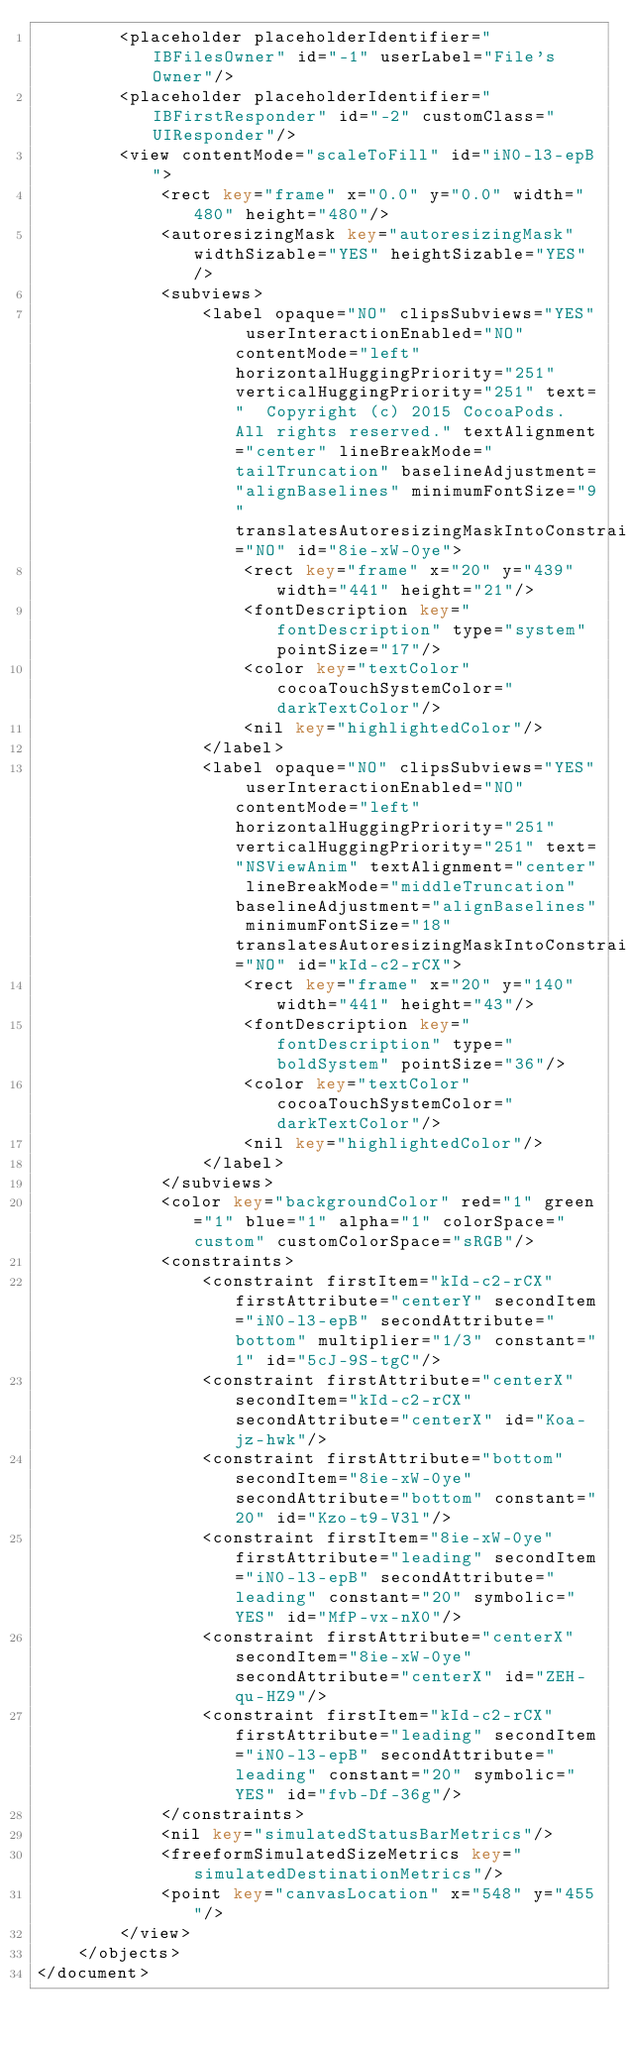<code> <loc_0><loc_0><loc_500><loc_500><_XML_>        <placeholder placeholderIdentifier="IBFilesOwner" id="-1" userLabel="File's Owner"/>
        <placeholder placeholderIdentifier="IBFirstResponder" id="-2" customClass="UIResponder"/>
        <view contentMode="scaleToFill" id="iN0-l3-epB">
            <rect key="frame" x="0.0" y="0.0" width="480" height="480"/>
            <autoresizingMask key="autoresizingMask" widthSizable="YES" heightSizable="YES"/>
            <subviews>
                <label opaque="NO" clipsSubviews="YES" userInteractionEnabled="NO" contentMode="left" horizontalHuggingPriority="251" verticalHuggingPriority="251" text="  Copyright (c) 2015 CocoaPods. All rights reserved." textAlignment="center" lineBreakMode="tailTruncation" baselineAdjustment="alignBaselines" minimumFontSize="9" translatesAutoresizingMaskIntoConstraints="NO" id="8ie-xW-0ye">
                    <rect key="frame" x="20" y="439" width="441" height="21"/>
                    <fontDescription key="fontDescription" type="system" pointSize="17"/>
                    <color key="textColor" cocoaTouchSystemColor="darkTextColor"/>
                    <nil key="highlightedColor"/>
                </label>
                <label opaque="NO" clipsSubviews="YES" userInteractionEnabled="NO" contentMode="left" horizontalHuggingPriority="251" verticalHuggingPriority="251" text="NSViewAnim" textAlignment="center" lineBreakMode="middleTruncation" baselineAdjustment="alignBaselines" minimumFontSize="18" translatesAutoresizingMaskIntoConstraints="NO" id="kId-c2-rCX">
                    <rect key="frame" x="20" y="140" width="441" height="43"/>
                    <fontDescription key="fontDescription" type="boldSystem" pointSize="36"/>
                    <color key="textColor" cocoaTouchSystemColor="darkTextColor"/>
                    <nil key="highlightedColor"/>
                </label>
            </subviews>
            <color key="backgroundColor" red="1" green="1" blue="1" alpha="1" colorSpace="custom" customColorSpace="sRGB"/>
            <constraints>
                <constraint firstItem="kId-c2-rCX" firstAttribute="centerY" secondItem="iN0-l3-epB" secondAttribute="bottom" multiplier="1/3" constant="1" id="5cJ-9S-tgC"/>
                <constraint firstAttribute="centerX" secondItem="kId-c2-rCX" secondAttribute="centerX" id="Koa-jz-hwk"/>
                <constraint firstAttribute="bottom" secondItem="8ie-xW-0ye" secondAttribute="bottom" constant="20" id="Kzo-t9-V3l"/>
                <constraint firstItem="8ie-xW-0ye" firstAttribute="leading" secondItem="iN0-l3-epB" secondAttribute="leading" constant="20" symbolic="YES" id="MfP-vx-nX0"/>
                <constraint firstAttribute="centerX" secondItem="8ie-xW-0ye" secondAttribute="centerX" id="ZEH-qu-HZ9"/>
                <constraint firstItem="kId-c2-rCX" firstAttribute="leading" secondItem="iN0-l3-epB" secondAttribute="leading" constant="20" symbolic="YES" id="fvb-Df-36g"/>
            </constraints>
            <nil key="simulatedStatusBarMetrics"/>
            <freeformSimulatedSizeMetrics key="simulatedDestinationMetrics"/>
            <point key="canvasLocation" x="548" y="455"/>
        </view>
    </objects>
</document>
</code> 